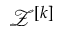Convert formula to latex. <formula><loc_0><loc_0><loc_500><loc_500>\mathcal { Z } ^ { [ k ] }</formula> 